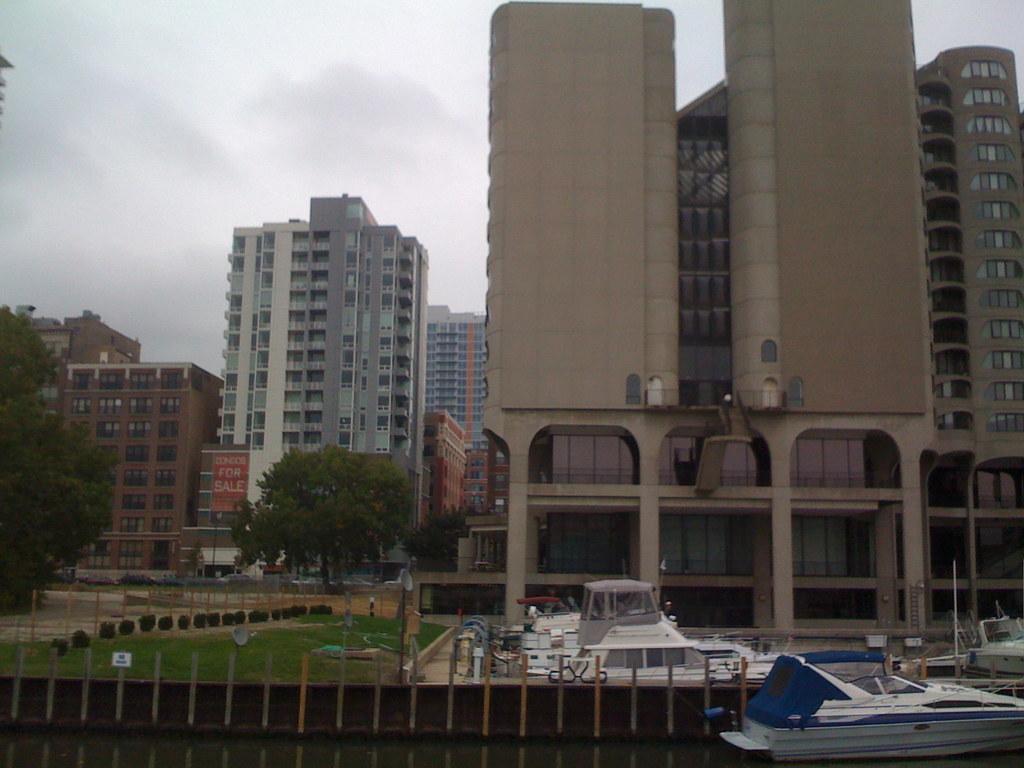In one or two sentences, can you explain what this image depicts? In the image we can see the buildings and these are the windows of the buildings. Here we can see the poles and there are boats in the water. Here we can see trees and the cloudy sky. 